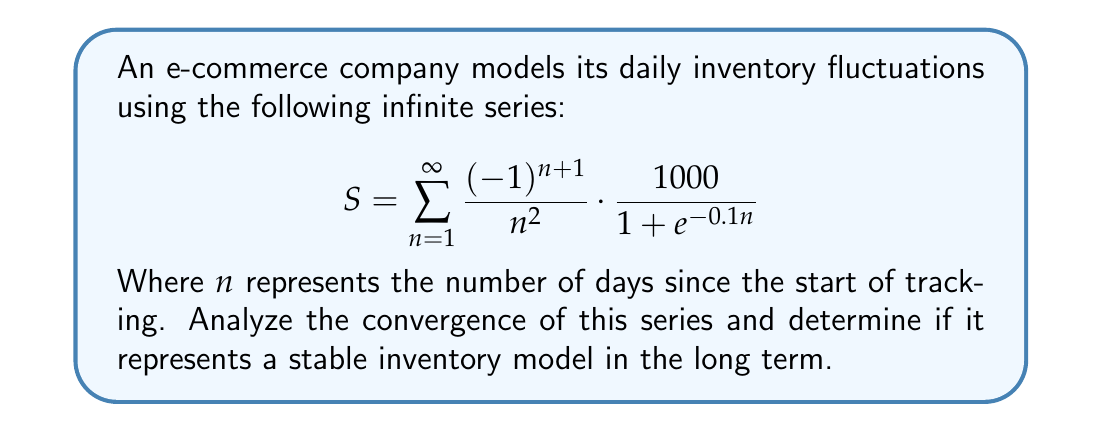Give your solution to this math problem. To analyze the convergence of this series, we'll use the following steps:

1) First, let's consider the behavior of the general term:

   $$a_n = \frac{(-1)^{n+1}}{n^2} \cdot \frac{1000}{1 + e^{-0.1n}}$$

2) We can split this into two parts:
   
   $$\frac{(-1)^{n+1}}{n^2} \text{ and } \frac{1000}{1 + e^{-0.1n}}$$

3) The first part, $\frac{(-1)^{n+1}}{n^2}$, is the general term of the alternating harmonic series of order 2, which is known to converge absolutely.

4) For the second part, as $n \to \infty$, $e^{-0.1n} \to 0$, so:

   $$\lim_{n \to \infty} \frac{1000}{1 + e^{-0.1n}} = 1000$$

5) Therefore, the general term behaves asymptotically like:

   $$a_n \sim \frac{(-1)^{n+1} \cdot 1000}{n^2}$$

6) We can use the limit comparison test with the series $\sum_{n=1}^{\infty} \frac{1}{n^2}$:

   $$\lim_{n \to \infty} \left|\frac{a_n}{1/n^2}\right| = \lim_{n \to \infty} \left|\frac{(-1)^{n+1} \cdot 1000}{n^2} \cdot n^2\right| = 1000$$

7) Since this limit exists and is finite, and $\sum_{n=1}^{\infty} \frac{1}{n^2}$ converges, our original series also converges absolutely.

8) Absolute convergence implies convergence, so the series converges.

Therefore, the series converges, representing a stable inventory model in the long term.
Answer: The series converges absolutely, indicating a stable long-term inventory model. 